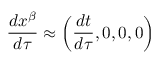<formula> <loc_0><loc_0><loc_500><loc_500>{ \frac { d x ^ { \beta } } { d \tau } } \approx \left ( { \frac { d t } { d \tau } } , 0 , 0 , 0 \right )</formula> 